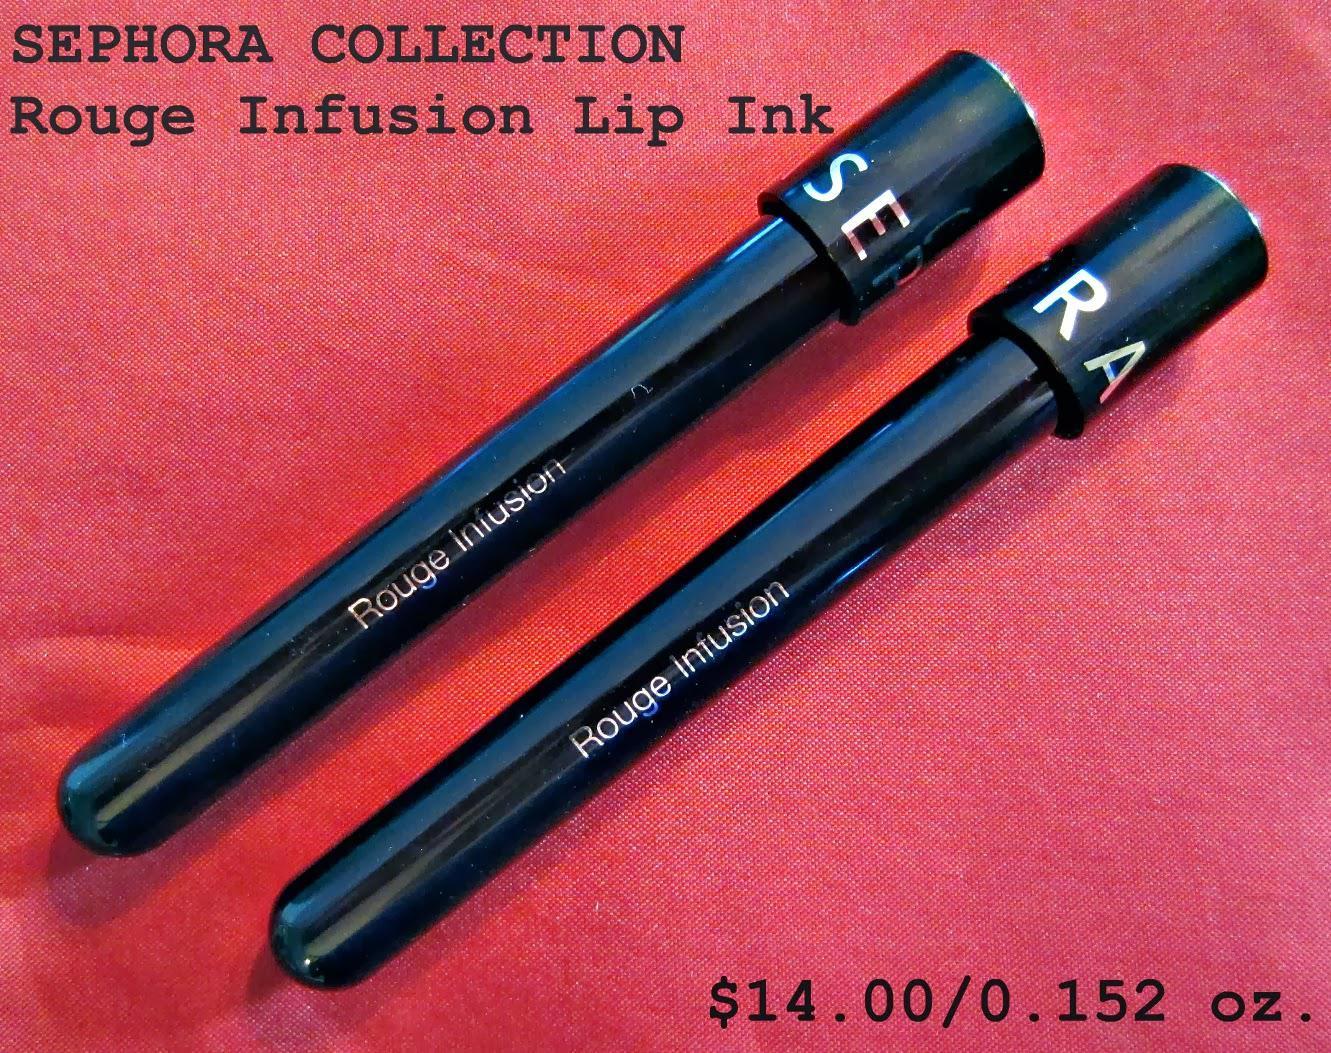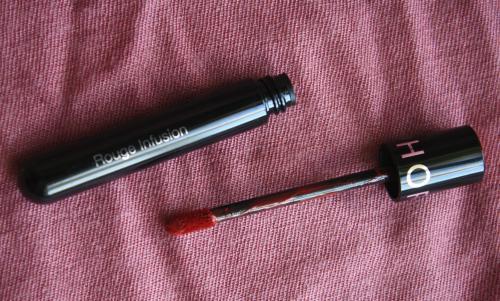The first image is the image on the left, the second image is the image on the right. Considering the images on both sides, is "There are three tubes of lipstick." valid? Answer yes or no. Yes. The first image is the image on the left, the second image is the image on the right. For the images displayed, is the sentence "The lipstick is shown on a person's lips in at least one of the images." factually correct? Answer yes or no. No. 